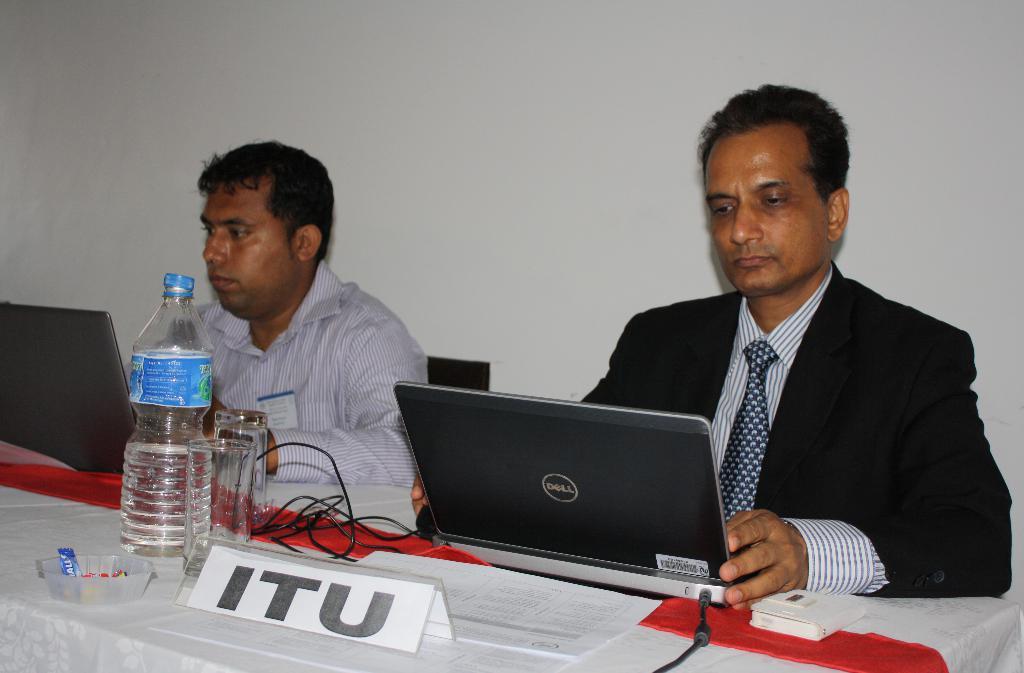What company is he with?
Give a very brief answer. Itu. What kind of laptop does he have?
Keep it short and to the point. Dell. 